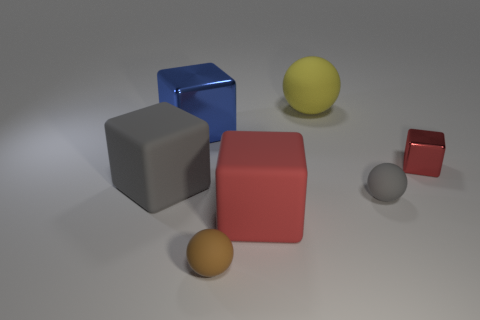Could you create a story using the objects in this image? Certainly! Once upon a time in a quiet studio, the geometric objects had a competition to see who could reflect the most light. The shiny blue cube, with its lustrous surface, boasted it would win, but the grey cube and the small red ball had plans of their own. As they positioned themselves to catch the beams from the overhead lights, a silent yet dazzling display unfolded, much to the delight of the observing orange ball who enjoyed the show from the sidelines. 